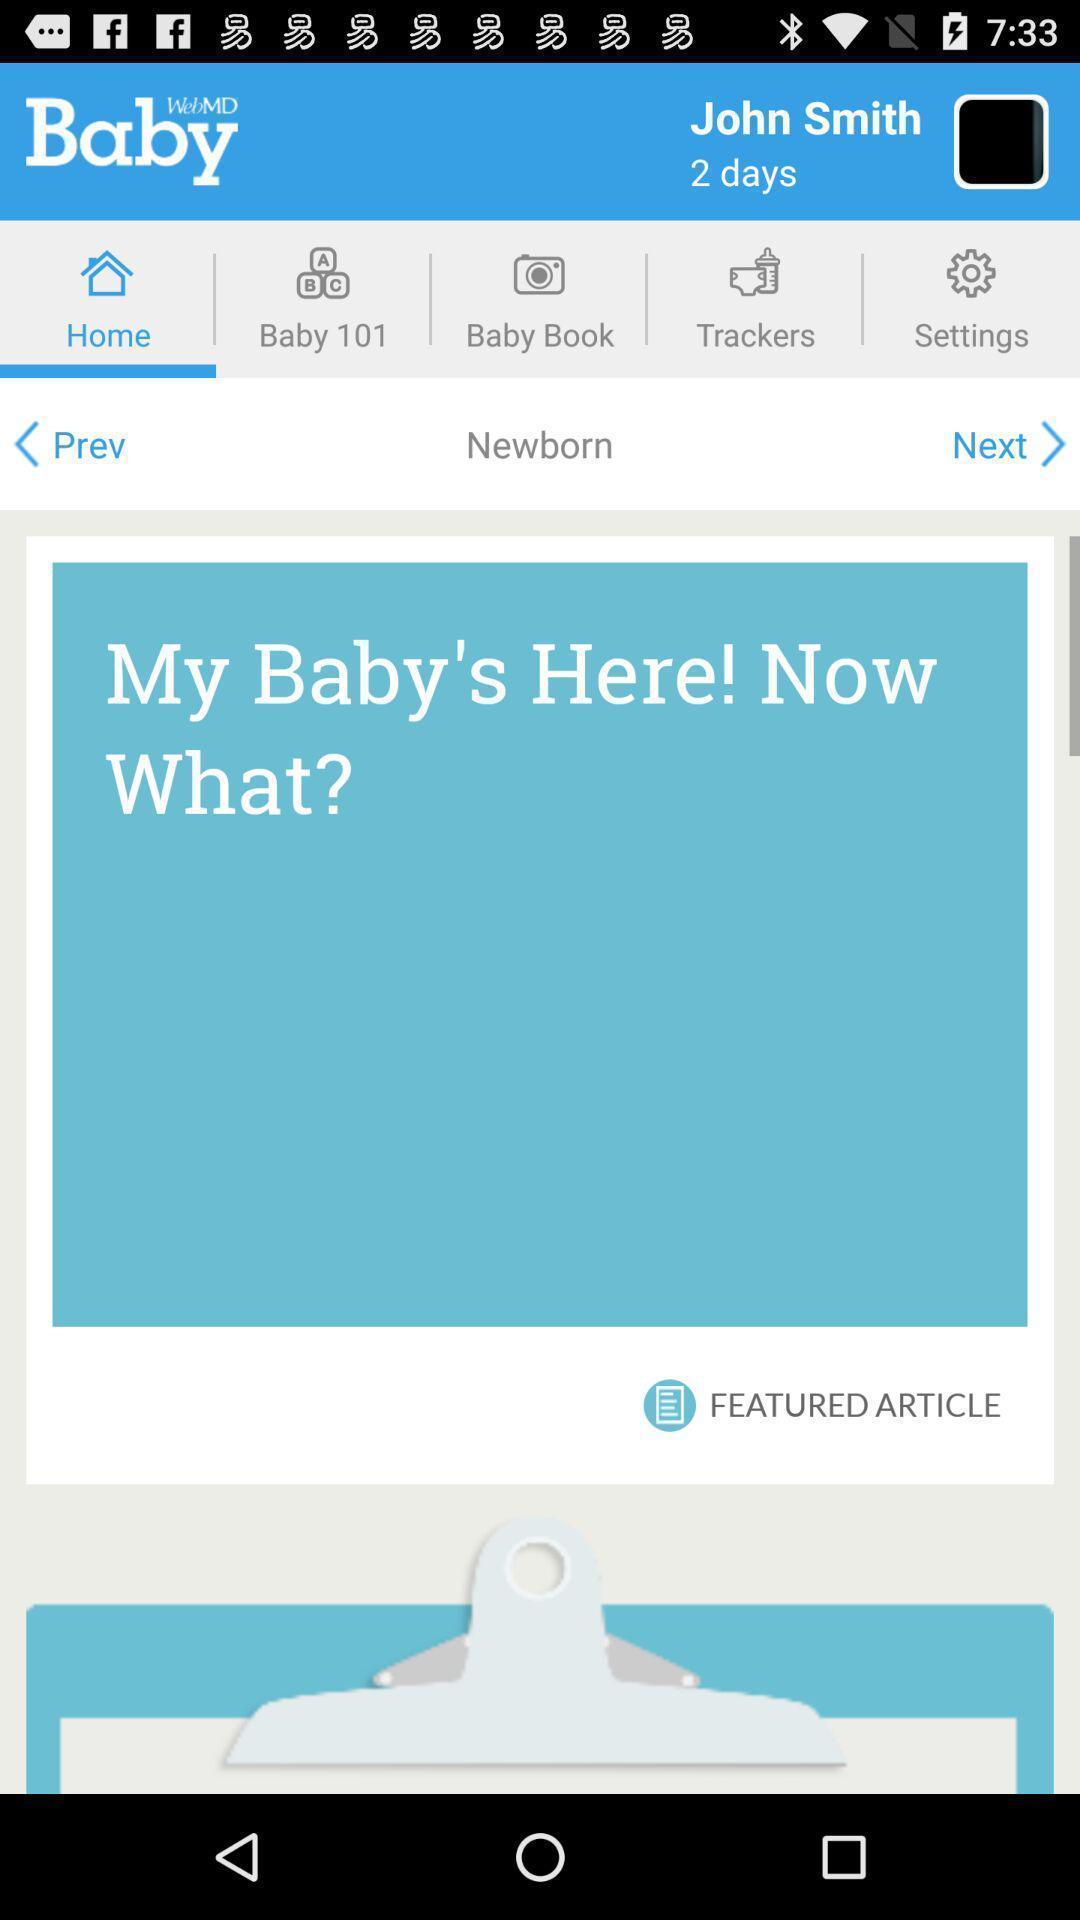What is the overall content of this screenshot? Screen shows homepage of baby development tracking app. 